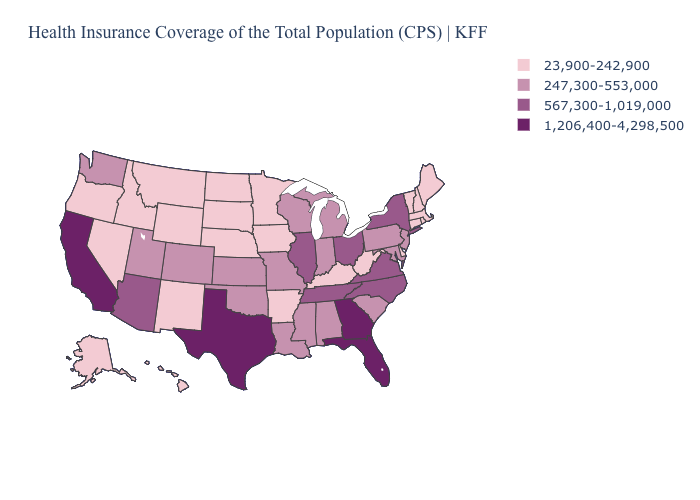Does Louisiana have the lowest value in the USA?
Be succinct. No. Name the states that have a value in the range 23,900-242,900?
Concise answer only. Alaska, Arkansas, Connecticut, Delaware, Hawaii, Idaho, Iowa, Kentucky, Maine, Massachusetts, Minnesota, Montana, Nebraska, Nevada, New Hampshire, New Mexico, North Dakota, Oregon, Rhode Island, South Dakota, Vermont, West Virginia, Wyoming. Does the map have missing data?
Short answer required. No. Does Kansas have the highest value in the MidWest?
Write a very short answer. No. What is the value of Montana?
Answer briefly. 23,900-242,900. Does Kansas have the same value as Rhode Island?
Answer briefly. No. Among the states that border Arkansas , does Texas have the highest value?
Quick response, please. Yes. What is the value of Nevada?
Keep it brief. 23,900-242,900. Does the map have missing data?
Short answer required. No. Does Minnesota have the lowest value in the MidWest?
Quick response, please. Yes. Does California have the highest value in the USA?
Short answer required. Yes. Which states have the lowest value in the MidWest?
Keep it brief. Iowa, Minnesota, Nebraska, North Dakota, South Dakota. What is the highest value in states that border Kansas?
Short answer required. 247,300-553,000. Does Kentucky have the lowest value in the USA?
Concise answer only. Yes. Which states have the lowest value in the USA?
Be succinct. Alaska, Arkansas, Connecticut, Delaware, Hawaii, Idaho, Iowa, Kentucky, Maine, Massachusetts, Minnesota, Montana, Nebraska, Nevada, New Hampshire, New Mexico, North Dakota, Oregon, Rhode Island, South Dakota, Vermont, West Virginia, Wyoming. 